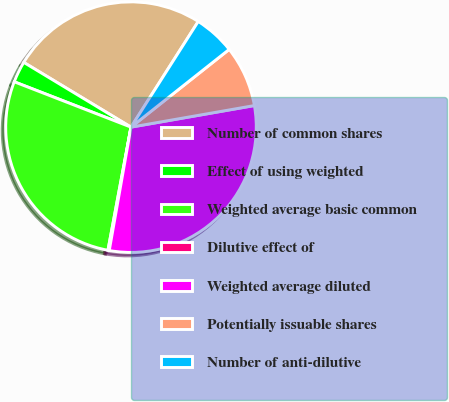Convert chart to OTSL. <chart><loc_0><loc_0><loc_500><loc_500><pie_chart><fcel>Number of common shares<fcel>Effect of using weighted<fcel>Weighted average basic common<fcel>Dilutive effect of<fcel>Weighted average diluted<fcel>Potentially issuable shares<fcel>Number of anti-dilutive<nl><fcel>25.37%<fcel>2.75%<fcel>27.95%<fcel>0.17%<fcel>30.53%<fcel>7.9%<fcel>5.32%<nl></chart> 